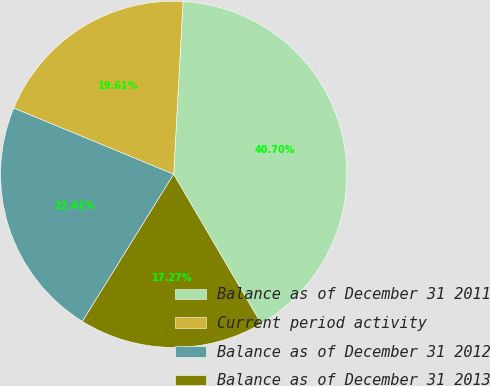Convert chart to OTSL. <chart><loc_0><loc_0><loc_500><loc_500><pie_chart><fcel>Balance as of December 31 2011<fcel>Current period activity<fcel>Balance as of December 31 2012<fcel>Balance as of December 31 2013<nl><fcel>40.7%<fcel>19.61%<fcel>22.41%<fcel>17.27%<nl></chart> 